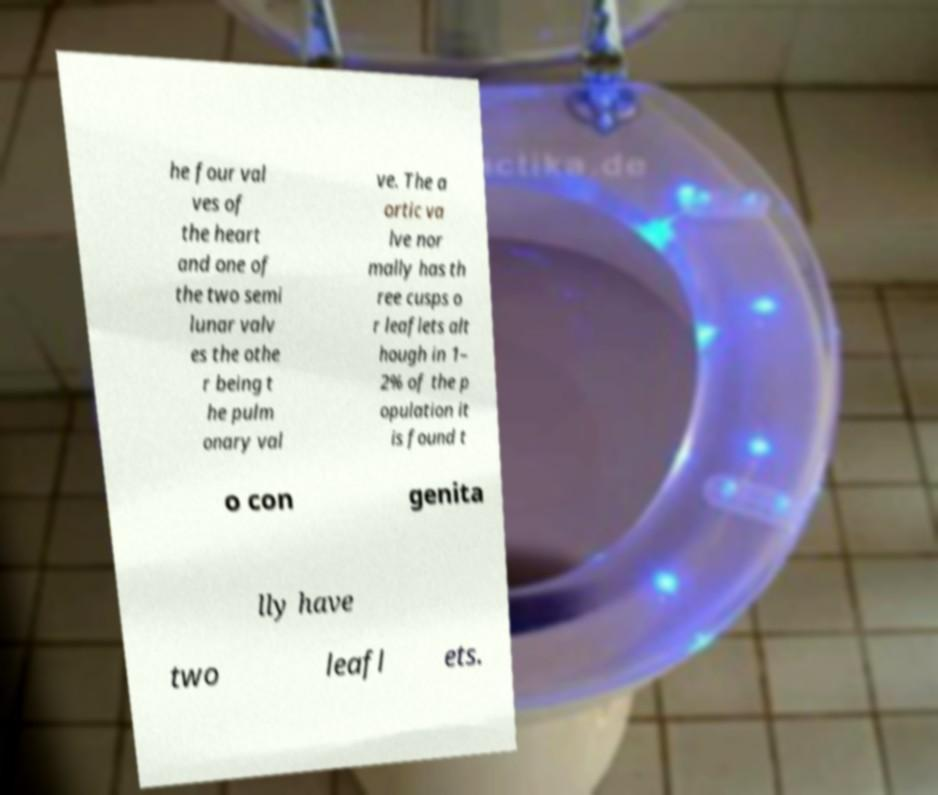For documentation purposes, I need the text within this image transcribed. Could you provide that? he four val ves of the heart and one of the two semi lunar valv es the othe r being t he pulm onary val ve. The a ortic va lve nor mally has th ree cusps o r leaflets alt hough in 1– 2% of the p opulation it is found t o con genita lly have two leafl ets. 